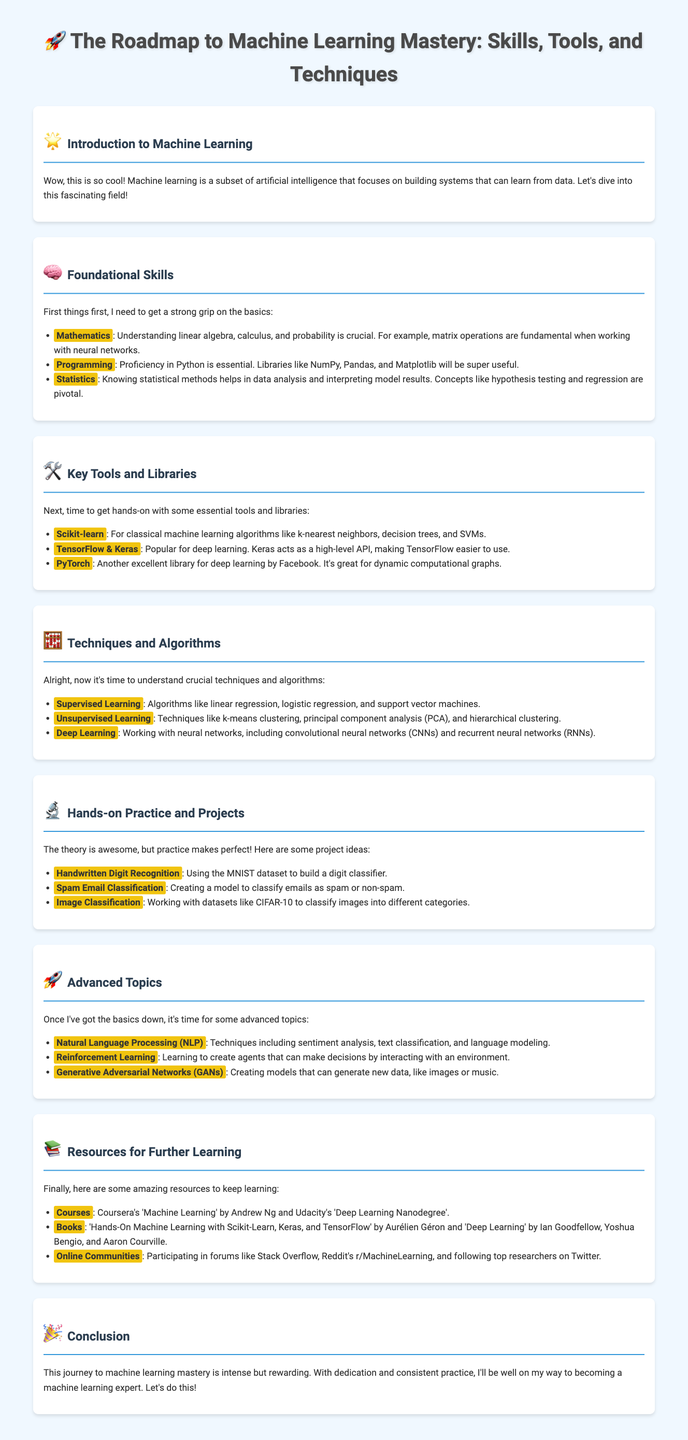What are the foundational skills needed for machine learning? The foundational skills include Mathematics, Programming, and Statistics, which are crucial for understanding machine learning concepts.
Answer: Mathematics, Programming, Statistics Which library is mentioned for classical machine learning algorithms? The document specifically mentions Scikit-learn for classical machine learning algorithms such as k-nearest neighbors and SVMs.
Answer: Scikit-learn Name one project idea from the hands-on practice section. The document lists several projects, including Handwritten Digit Recognition, which utilizes the MNIST dataset.
Answer: Handwritten Digit Recognition What advanced topic involves creating models that can generate new data? Generative Adversarial Networks (GANs) is mentioned as the advanced topic related to creating new data models.
Answer: Generative Adversarial Networks How many key tools and libraries are listed in the document? The document enumerates three key tools and libraries necessary for machine learning practice.
Answer: Three What is the title of the document? The title of the infographic page summarizes the focus on mastering machine learning skills and techniques.
Answer: The Roadmap to Machine Learning Mastery Who is the author of the recommended course on Coursera? The course on Coursera, recommended in the Resources section, is taught by Andrew Ng.
Answer: Andrew Ng Which emoji represents the introduction section? The introductory section is represented by a star emoji, which indicates the beginning of the roadmap.
Answer: 🌟 What is a key statistical method necessary for data analysis? The document notes that knowledge of hypothesis testing is pivotal for analyzing data and interpreting results.
Answer: Hypothesis testing 